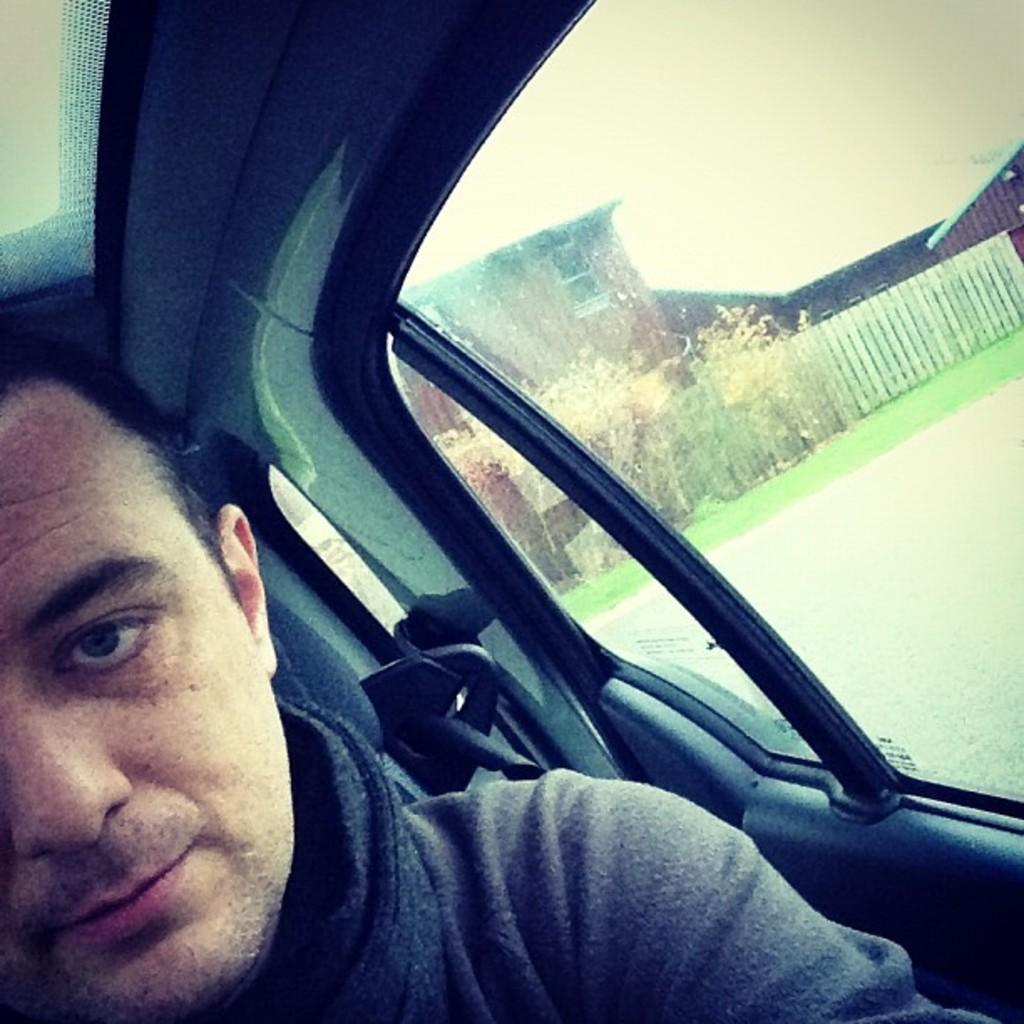Who is present in the image? There is a person in the image. What is the person wearing? The person is wearing a black dress. Where is the person located in the image? The person is sitting in a car. What can be seen in the background of the image? There is a house and trees in the background of the image. What type of teaching is the person doing in the image? There is no indication of teaching in the image; the person is simply sitting in a car. How many giants are visible in the image? There are no giants present in the image. 